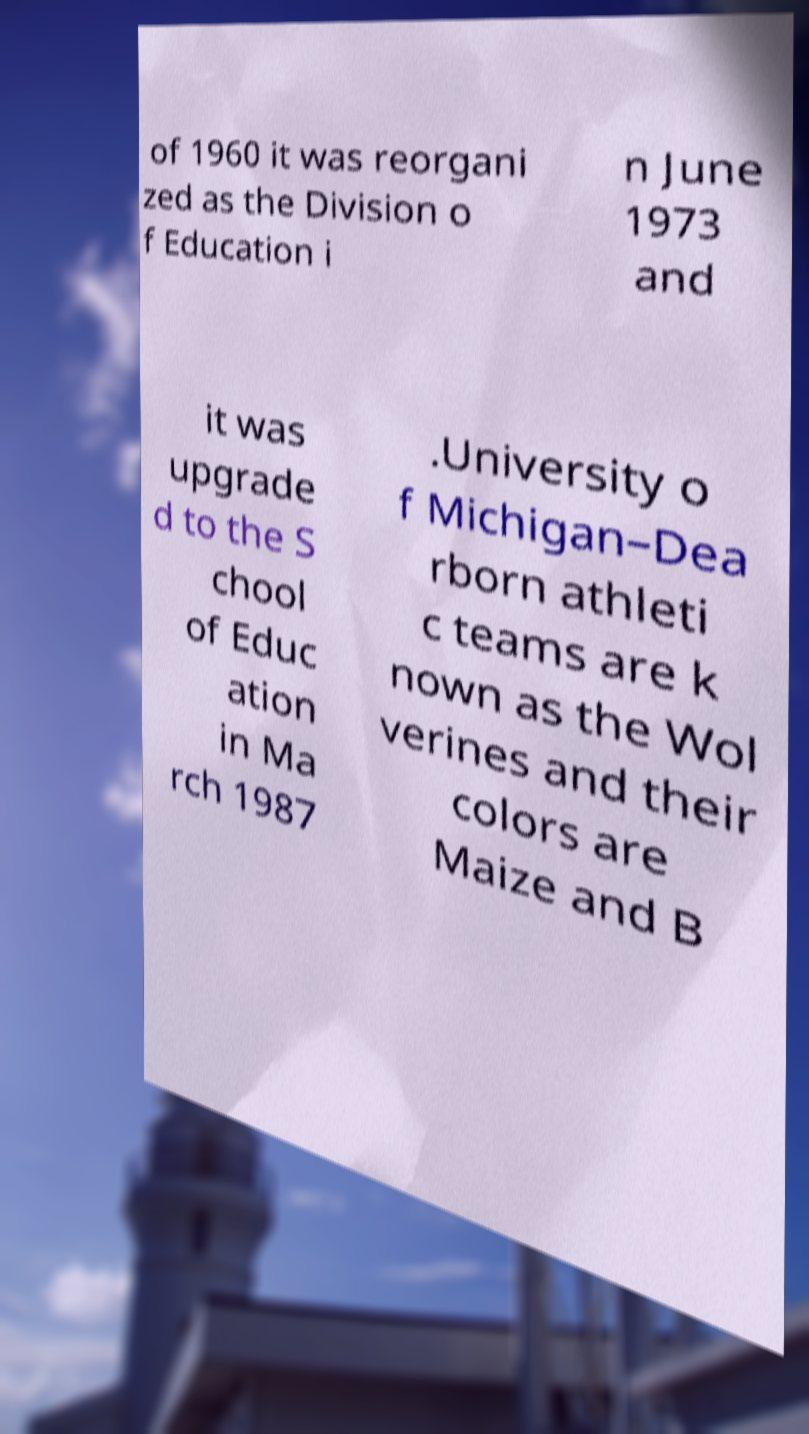Please read and relay the text visible in this image. What does it say? of 1960 it was reorgani zed as the Division o f Education i n June 1973 and it was upgrade d to the S chool of Educ ation in Ma rch 1987 .University o f Michigan–Dea rborn athleti c teams are k nown as the Wol verines and their colors are Maize and B 